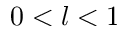Convert formula to latex. <formula><loc_0><loc_0><loc_500><loc_500>0 < l < 1</formula> 